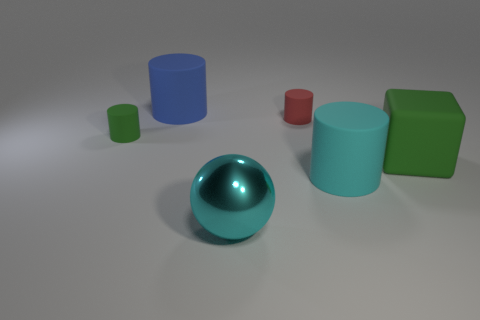How many other objects are there of the same size as the green matte cylinder? Upon reviewing the image, there appears to be one object, a red cylinder, that may be of similar size to the green matte cylinder in terms of height, but this assessment is only an estimate without exact measurements. In a real-world application, one would need precise data to determine size equivalence. 